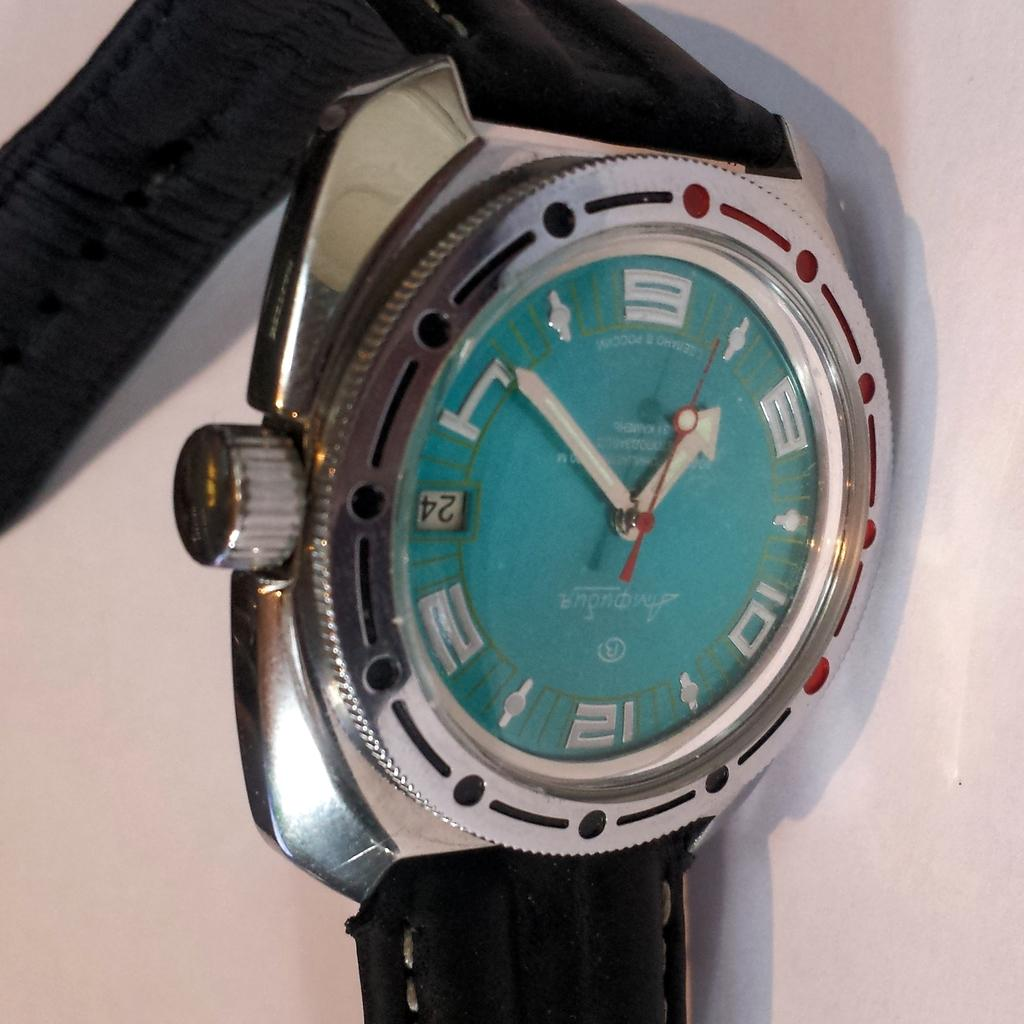<image>
Share a concise interpretation of the image provided. A watch with a blue face says that today is the 24th. 